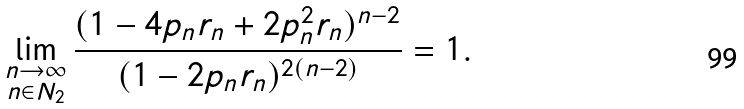Convert formula to latex. <formula><loc_0><loc_0><loc_500><loc_500>\lim _ { \substack { n \rightarrow \infty \\ n \in N _ { 2 } } } \frac { ( 1 - 4 p _ { n } r _ { n } + 2 p _ { n } ^ { 2 } r _ { n } ) ^ { n - 2 } } { ( 1 - 2 p _ { n } r _ { n } ) ^ { 2 ( n - 2 ) } } = 1 .</formula> 